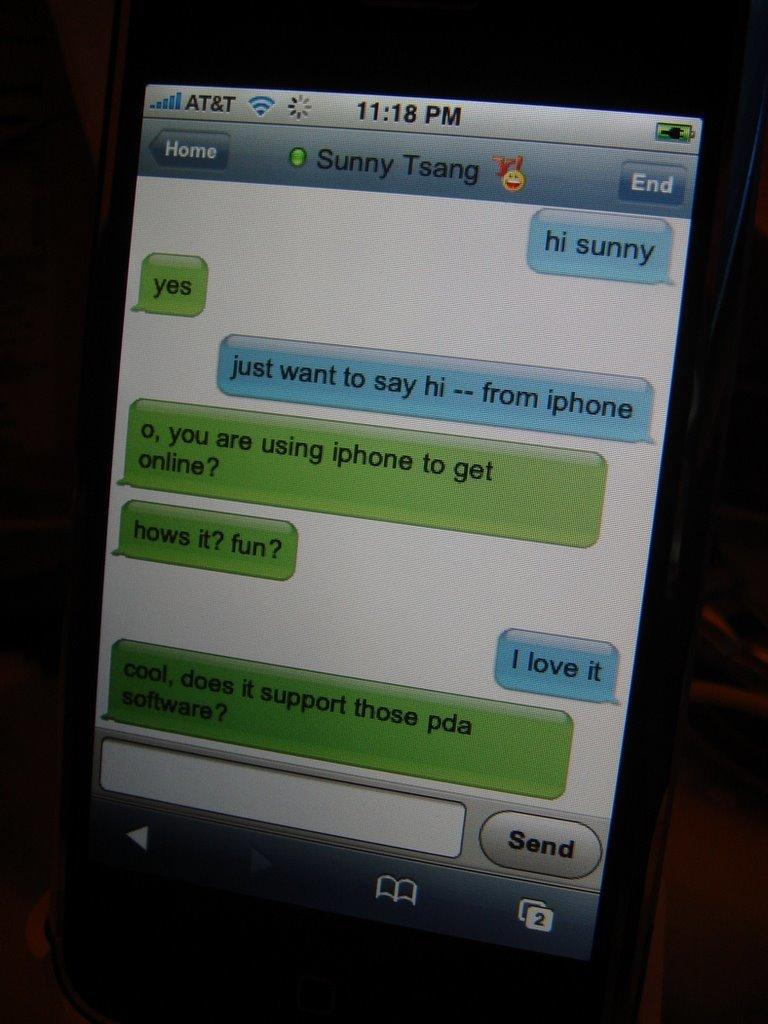Provide a one-sentence caption for the provided image. A display shows texts from Sunny Tsang at 11:18 pm. 